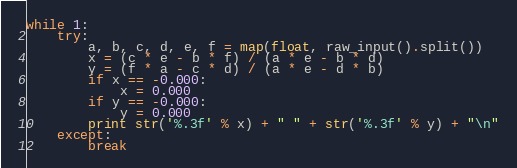<code> <loc_0><loc_0><loc_500><loc_500><_Python_>while 1:
    try:
        a, b, c, d, e, f = map(float, raw_input().split())
        x = (c * e - b * f) / (a * e - b * d)
        y = (f * a - c * d) / (a * e - d * b)
        if x == -0.000:
            x = 0.000
        if y == -0.000:
            y = 0.000
        print str('%.3f' % x) + " " + str('%.3f' % y) + "\n"
    except:
        break</code> 